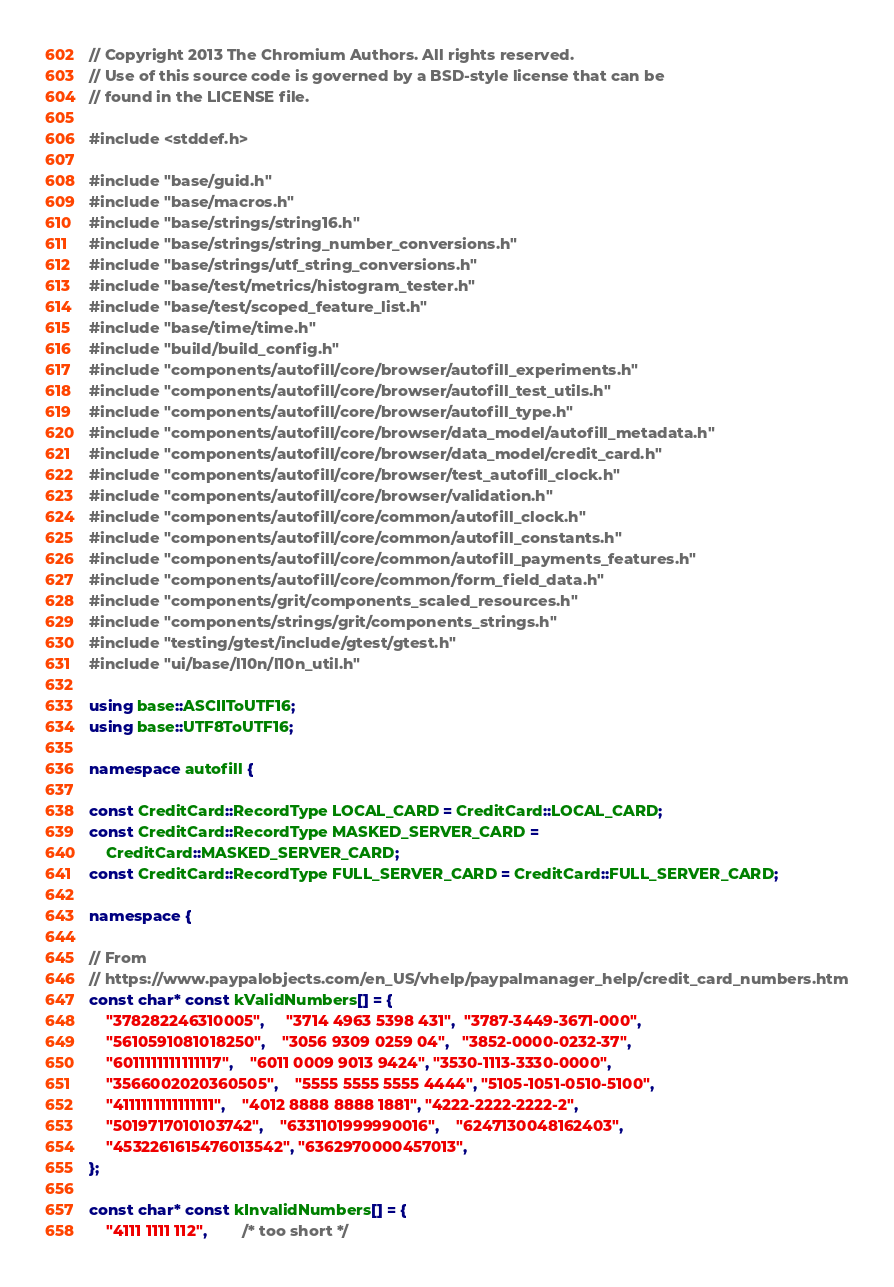<code> <loc_0><loc_0><loc_500><loc_500><_C++_>// Copyright 2013 The Chromium Authors. All rights reserved.
// Use of this source code is governed by a BSD-style license that can be
// found in the LICENSE file.

#include <stddef.h>

#include "base/guid.h"
#include "base/macros.h"
#include "base/strings/string16.h"
#include "base/strings/string_number_conversions.h"
#include "base/strings/utf_string_conversions.h"
#include "base/test/metrics/histogram_tester.h"
#include "base/test/scoped_feature_list.h"
#include "base/time/time.h"
#include "build/build_config.h"
#include "components/autofill/core/browser/autofill_experiments.h"
#include "components/autofill/core/browser/autofill_test_utils.h"
#include "components/autofill/core/browser/autofill_type.h"
#include "components/autofill/core/browser/data_model/autofill_metadata.h"
#include "components/autofill/core/browser/data_model/credit_card.h"
#include "components/autofill/core/browser/test_autofill_clock.h"
#include "components/autofill/core/browser/validation.h"
#include "components/autofill/core/common/autofill_clock.h"
#include "components/autofill/core/common/autofill_constants.h"
#include "components/autofill/core/common/autofill_payments_features.h"
#include "components/autofill/core/common/form_field_data.h"
#include "components/grit/components_scaled_resources.h"
#include "components/strings/grit/components_strings.h"
#include "testing/gtest/include/gtest/gtest.h"
#include "ui/base/l10n/l10n_util.h"

using base::ASCIIToUTF16;
using base::UTF8ToUTF16;

namespace autofill {

const CreditCard::RecordType LOCAL_CARD = CreditCard::LOCAL_CARD;
const CreditCard::RecordType MASKED_SERVER_CARD =
    CreditCard::MASKED_SERVER_CARD;
const CreditCard::RecordType FULL_SERVER_CARD = CreditCard::FULL_SERVER_CARD;

namespace {

// From
// https://www.paypalobjects.com/en_US/vhelp/paypalmanager_help/credit_card_numbers.htm
const char* const kValidNumbers[] = {
    "378282246310005",     "3714 4963 5398 431",  "3787-3449-3671-000",
    "5610591081018250",    "3056 9309 0259 04",   "3852-0000-0232-37",
    "6011111111111117",    "6011 0009 9013 9424", "3530-1113-3330-0000",
    "3566002020360505",    "5555 5555 5555 4444", "5105-1051-0510-5100",
    "4111111111111111",    "4012 8888 8888 1881", "4222-2222-2222-2",
    "5019717010103742",    "6331101999990016",    "6247130048162403",
    "4532261615476013542", "6362970000457013",
};

const char* const kInvalidNumbers[] = {
    "4111 1111 112",        /* too short */</code> 